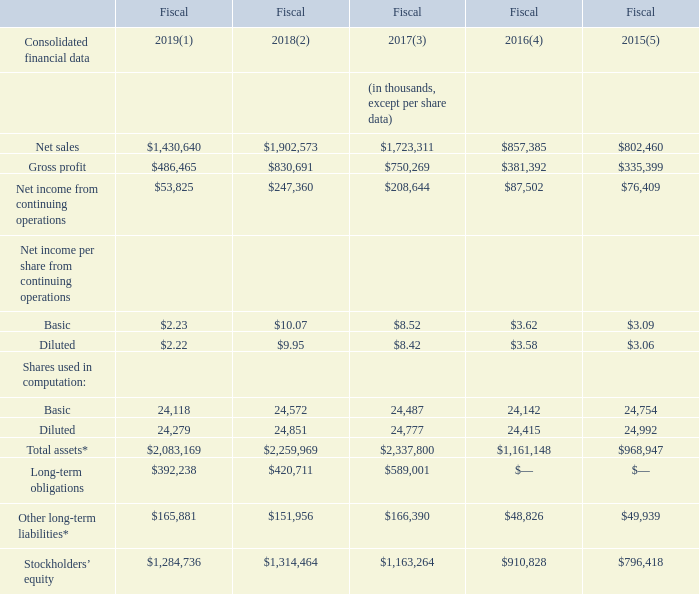ITEM 6. SELECTED FINANCIAL DATA
The information set forth below is not necessarily indicative of results of future operations and should be read in conjunction with Item 7. ‘‘Management’s Discussion and Analysis of Financial Condition and Results of Operations’’ and the Consolidated Financial Statements and Notes to Consolidated Financial Statements included elsewhere in this annual report.
We derived the consolidated statement of operations data for fiscal 2019, 2018 and 2017 and the consolidated balance sheet data as of fiscal 2019 and 2018 year-end from our audited consolidated financial statements, and accompanying notes, contained in this annual report. The consolidated statements of operations data for fiscal 2016 and 2015 and the consolidated balance sheet data as of fiscal 2017, 2016 and 2015 year-end are derived from our audited consolidated financial statements which are not included in this annual report.
* In November 2015, the FASB issued amended guidance that clarifies that in a classified statement of financial position, an entity shall classify deferred tax liabilities and assets as noncurrent amounts. This guidance superseded ASC 740-10-45-5 which required the valuation allowance for a particular tax jurisdiction be allocated between current and noncurrent deferred tax assets for that tax jurisdiction on a pro rata basis. We elected to early adopt the standard retrospectively in fiscal 2016, which resulted in the reclassification of current deferred income tax assets to non-current deferred income tax assets and non-current deferred income tax liabilities on our consolidated balance sheets for fiscal 2017, 2016 and 2015.
(1) Includes $16.0 million of after-tax restructuring charges, $0.4 million of after-tax amortization of purchase accounting step-up, $1.1 million of benefit from amounts received on a resolved asset recovery matter, $1.7 million non-recurring income tax net expense and $2.5 million of excess tax benefits for employee stock-based compensation.
(2) Includes $2.9 million of after-tax restructuring charges, $0.8 million impairment and other charges, $0.7 million of after-tax acquisition costs, $0.6 million of after-tax amortization of purchase accounting step-up, $26.7 million of tax charges due to the U.S. Tax Cuts and Jobs Act transition tax and deferred tax remeasurement, $3.3 million tax charge due to an increase in valuation allowances against deferred tax assets and $12.8 million of tax benefit from the adoption of new rules for accounting for excess tax benefits and tax deficiencies for employee stock-based compensation.
(3) Includes $19.0 million of after-tax amortization of purchase accounting step-up, $17.4 million of after tax costs related to the acquisition of Rofin, $8.4 million of after-tax restructuring charges, an after-tax charge of $1.9 million for the impairment of net assets of several entities held for sale, $1.8 million after-tax interest expense on the commitment of our term loan to finance the acquisition of Rofin, a $7.1 million after-tax gain on our hedge of our foreign exchange risk related to the commitment of our term loan and the issuance of debt to finance the acquisition of Rofin, a $3.4 million after-tax gain on our sale of previously owned Rofin shares and a benefit of $1.4 million from the closure of R&D tax audits.
(4) Includes $6.4 million of after tax costs related to the acquisition of Rofin, a $1.4 million after-tax loss on our hedge of our foreign exchange risk related to the commitment of our term loan to finance the acquisition of Rofin, $0.8 million after-tax interest expense on the commitment of our term loan to finance the acquisition of Rofin and a benefit of $1.2 million from the renewal of the R&D tax credit for fiscal 2015.
(5) Includes a charge of $1.3 million after tax for the impairment of our investment in SiOnyx, a $1.3 million after-tax charge for an accrual related to an ongoing customs audit, a benefit of $1.1 million from the renewal of the R&D tax credit for fiscal 2014 and a $1.3 million gain on our purchase of Tinsley in the fourth quarter of fiscal 2015.
What does the amount for fiscal 2019 include? Includes $16.0 million of after-tax restructuring charges, $0.4 million of after-tax amortization of purchase accounting step-up, $1.1 million of benefit from amounts received on a resolved asset recovery matter, $1.7 million non-recurring income tax net expense and $2.5 million of excess tax benefits for employee stock-based compensation. What is the  Net sales for 2019?
Answer scale should be: thousand. $1,430,640. In which years was the selected financial data provided? 2019, 2018, 2017, 2016, 2015. In which year was the Diluted Net income per share from continuing operations largest? 9.95>8.42>3.58>3.06>2.22
Answer: 2018. What was the change in Diluted Net income per share from continuing operations in 2018 from 2017? 9.95-8.42
Answer: 1.53. What was the percentage change in Diluted Net income per share from continuing operations in 2018 from 2017?
Answer scale should be: percent. (9.95-8.42)/8.42
Answer: 18.17. 